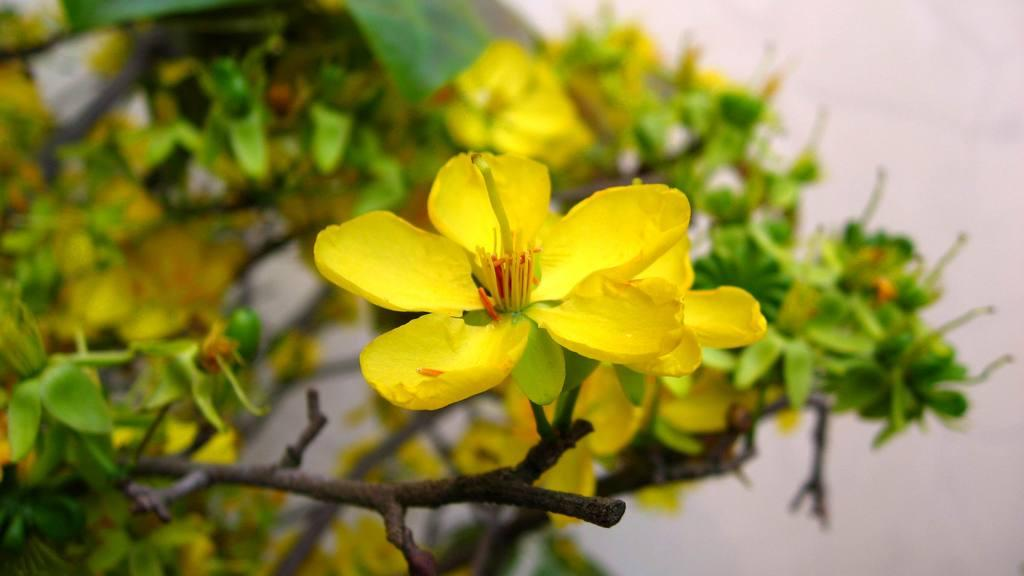What type of plants can be seen in the image? There are flowering plants in the image. What can be seen in the background of the image? There is a wall visible in the background of the image. Where might this image have been taken? The image may have been taken in a garden, given the presence of flowering plants. How often does the person in the image need a haircut? There is no person present in the image, so it is impossible to determine how often they might need a haircut. 